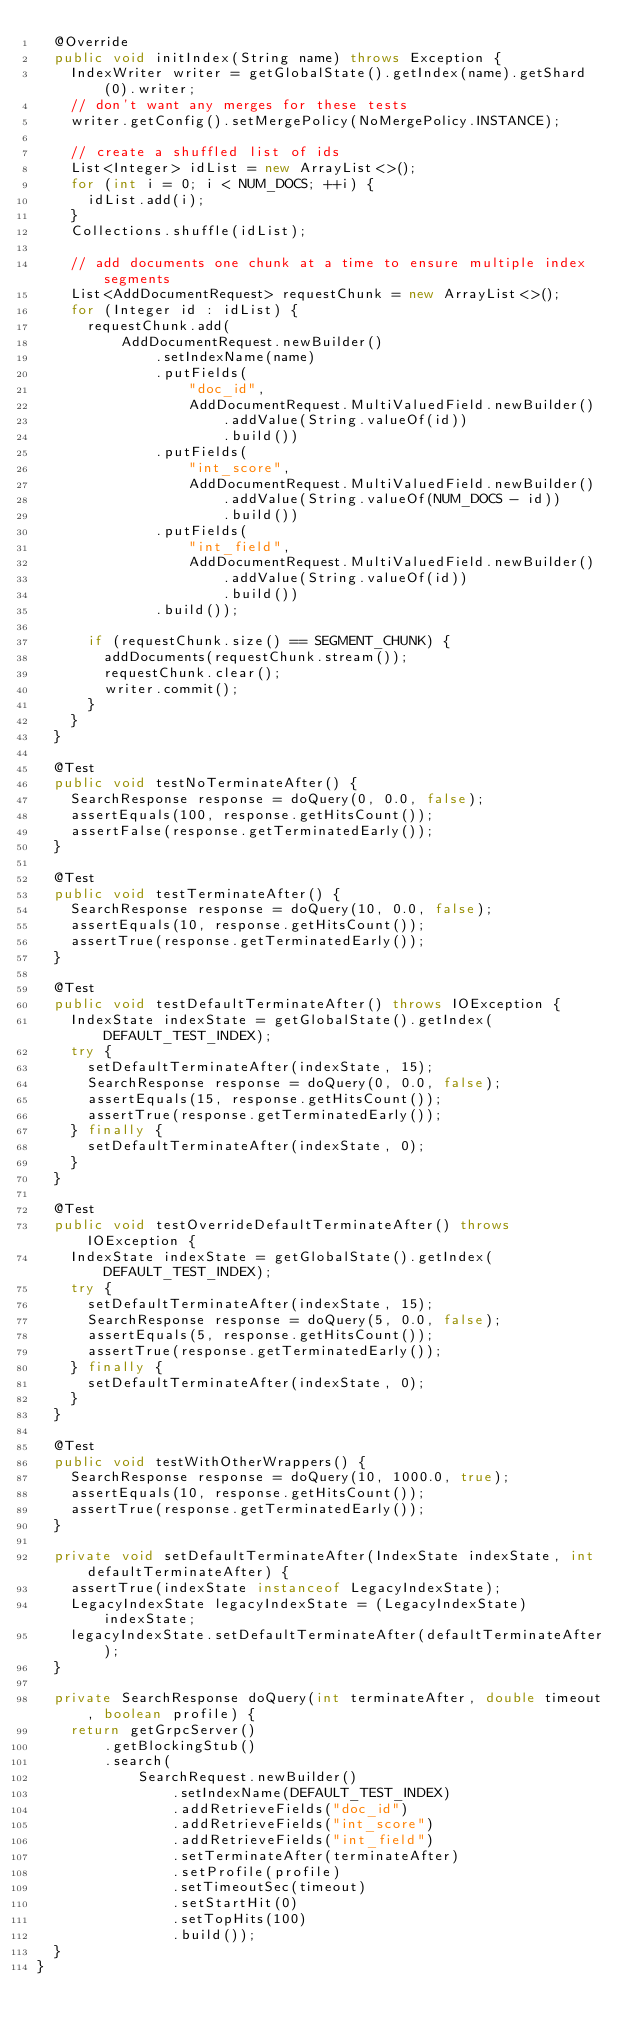<code> <loc_0><loc_0><loc_500><loc_500><_Java_>  @Override
  public void initIndex(String name) throws Exception {
    IndexWriter writer = getGlobalState().getIndex(name).getShard(0).writer;
    // don't want any merges for these tests
    writer.getConfig().setMergePolicy(NoMergePolicy.INSTANCE);

    // create a shuffled list of ids
    List<Integer> idList = new ArrayList<>();
    for (int i = 0; i < NUM_DOCS; ++i) {
      idList.add(i);
    }
    Collections.shuffle(idList);

    // add documents one chunk at a time to ensure multiple index segments
    List<AddDocumentRequest> requestChunk = new ArrayList<>();
    for (Integer id : idList) {
      requestChunk.add(
          AddDocumentRequest.newBuilder()
              .setIndexName(name)
              .putFields(
                  "doc_id",
                  AddDocumentRequest.MultiValuedField.newBuilder()
                      .addValue(String.valueOf(id))
                      .build())
              .putFields(
                  "int_score",
                  AddDocumentRequest.MultiValuedField.newBuilder()
                      .addValue(String.valueOf(NUM_DOCS - id))
                      .build())
              .putFields(
                  "int_field",
                  AddDocumentRequest.MultiValuedField.newBuilder()
                      .addValue(String.valueOf(id))
                      .build())
              .build());

      if (requestChunk.size() == SEGMENT_CHUNK) {
        addDocuments(requestChunk.stream());
        requestChunk.clear();
        writer.commit();
      }
    }
  }

  @Test
  public void testNoTerminateAfter() {
    SearchResponse response = doQuery(0, 0.0, false);
    assertEquals(100, response.getHitsCount());
    assertFalse(response.getTerminatedEarly());
  }

  @Test
  public void testTerminateAfter() {
    SearchResponse response = doQuery(10, 0.0, false);
    assertEquals(10, response.getHitsCount());
    assertTrue(response.getTerminatedEarly());
  }

  @Test
  public void testDefaultTerminateAfter() throws IOException {
    IndexState indexState = getGlobalState().getIndex(DEFAULT_TEST_INDEX);
    try {
      setDefaultTerminateAfter(indexState, 15);
      SearchResponse response = doQuery(0, 0.0, false);
      assertEquals(15, response.getHitsCount());
      assertTrue(response.getTerminatedEarly());
    } finally {
      setDefaultTerminateAfter(indexState, 0);
    }
  }

  @Test
  public void testOverrideDefaultTerminateAfter() throws IOException {
    IndexState indexState = getGlobalState().getIndex(DEFAULT_TEST_INDEX);
    try {
      setDefaultTerminateAfter(indexState, 15);
      SearchResponse response = doQuery(5, 0.0, false);
      assertEquals(5, response.getHitsCount());
      assertTrue(response.getTerminatedEarly());
    } finally {
      setDefaultTerminateAfter(indexState, 0);
    }
  }

  @Test
  public void testWithOtherWrappers() {
    SearchResponse response = doQuery(10, 1000.0, true);
    assertEquals(10, response.getHitsCount());
    assertTrue(response.getTerminatedEarly());
  }

  private void setDefaultTerminateAfter(IndexState indexState, int defaultTerminateAfter) {
    assertTrue(indexState instanceof LegacyIndexState);
    LegacyIndexState legacyIndexState = (LegacyIndexState) indexState;
    legacyIndexState.setDefaultTerminateAfter(defaultTerminateAfter);
  }

  private SearchResponse doQuery(int terminateAfter, double timeout, boolean profile) {
    return getGrpcServer()
        .getBlockingStub()
        .search(
            SearchRequest.newBuilder()
                .setIndexName(DEFAULT_TEST_INDEX)
                .addRetrieveFields("doc_id")
                .addRetrieveFields("int_score")
                .addRetrieveFields("int_field")
                .setTerminateAfter(terminateAfter)
                .setProfile(profile)
                .setTimeoutSec(timeout)
                .setStartHit(0)
                .setTopHits(100)
                .build());
  }
}
</code> 